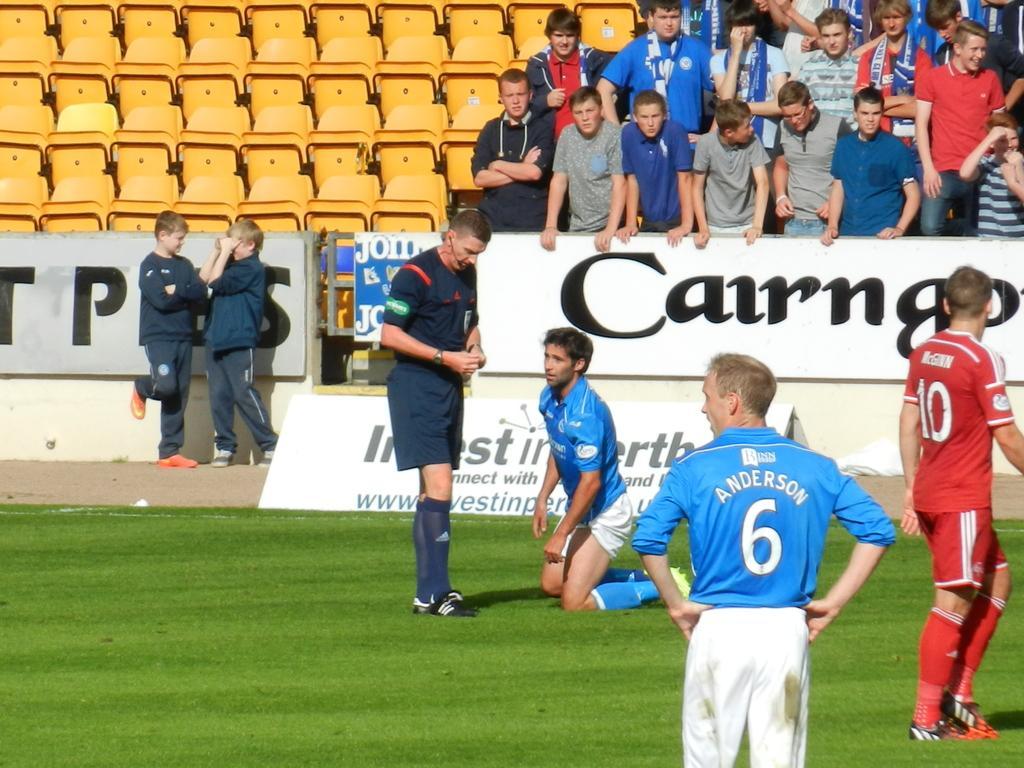Please provide a concise description of this image. In this image, we can see four person and grass. In the background, we can see banners, people and seats. 